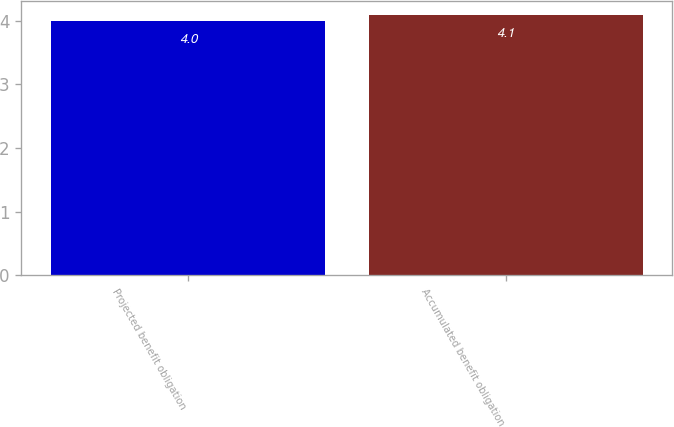Convert chart. <chart><loc_0><loc_0><loc_500><loc_500><bar_chart><fcel>Projected benefit obligation<fcel>Accumulated benefit obligation<nl><fcel>4<fcel>4.1<nl></chart> 